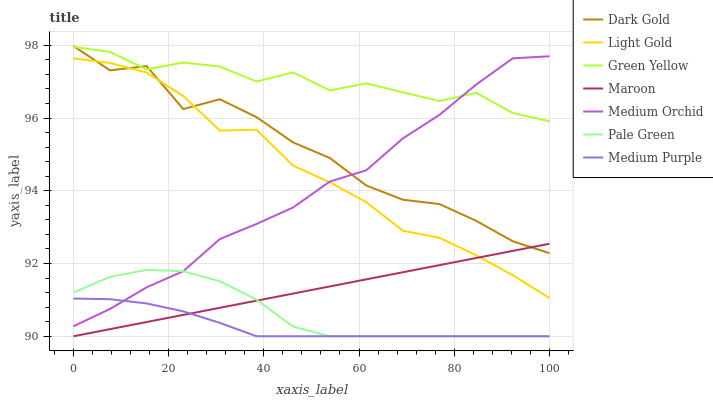Does Medium Purple have the minimum area under the curve?
Answer yes or no. Yes. Does Green Yellow have the maximum area under the curve?
Answer yes or no. Yes. Does Medium Orchid have the minimum area under the curve?
Answer yes or no. No. Does Medium Orchid have the maximum area under the curve?
Answer yes or no. No. Is Maroon the smoothest?
Answer yes or no. Yes. Is Dark Gold the roughest?
Answer yes or no. Yes. Is Medium Orchid the smoothest?
Answer yes or no. No. Is Medium Orchid the roughest?
Answer yes or no. No. Does Maroon have the lowest value?
Answer yes or no. Yes. Does Medium Orchid have the lowest value?
Answer yes or no. No. Does Dark Gold have the highest value?
Answer yes or no. Yes. Does Medium Orchid have the highest value?
Answer yes or no. No. Is Medium Purple less than Green Yellow?
Answer yes or no. Yes. Is Green Yellow greater than Light Gold?
Answer yes or no. Yes. Does Medium Orchid intersect Green Yellow?
Answer yes or no. Yes. Is Medium Orchid less than Green Yellow?
Answer yes or no. No. Is Medium Orchid greater than Green Yellow?
Answer yes or no. No. Does Medium Purple intersect Green Yellow?
Answer yes or no. No. 